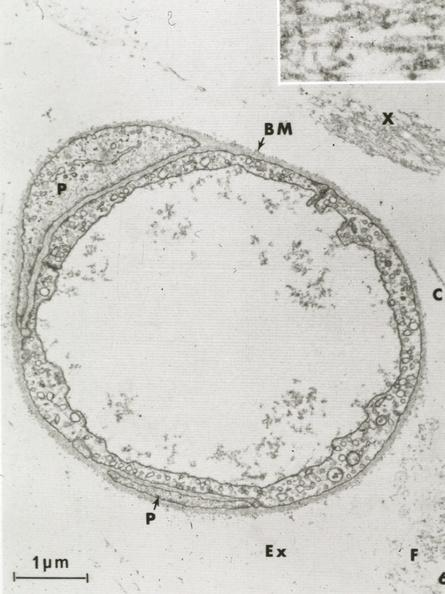does papillary intraductal adenocarcinoma show continuous type?
Answer the question using a single word or phrase. No 